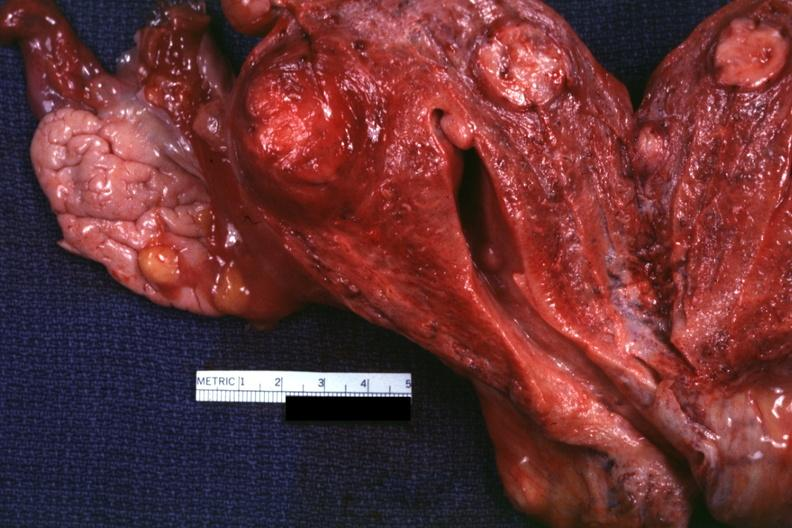s leiomyoma present?
Answer the question using a single word or phrase. Yes 